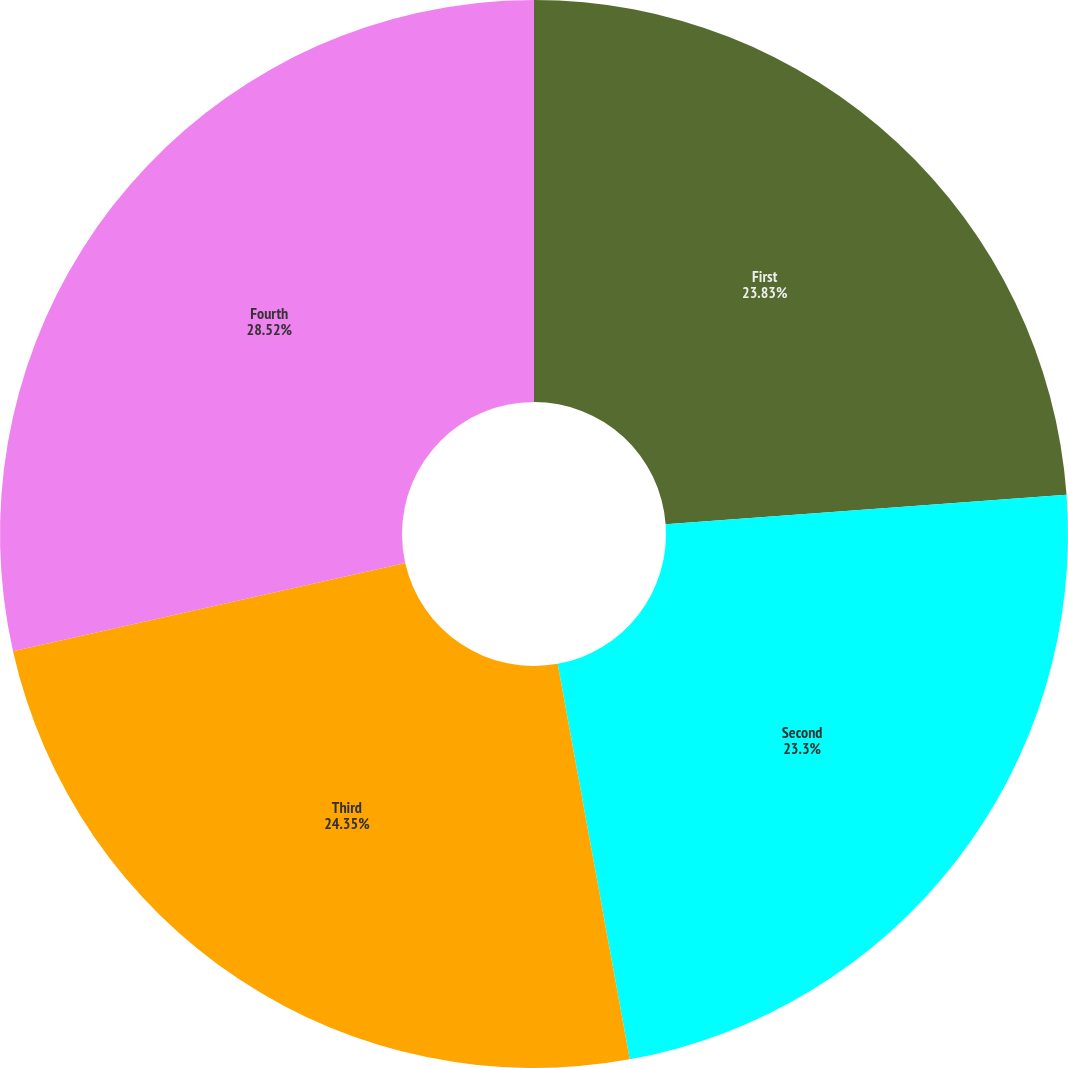Convert chart. <chart><loc_0><loc_0><loc_500><loc_500><pie_chart><fcel>First<fcel>Second<fcel>Third<fcel>Fourth<nl><fcel>23.83%<fcel>23.3%<fcel>24.35%<fcel>28.52%<nl></chart> 